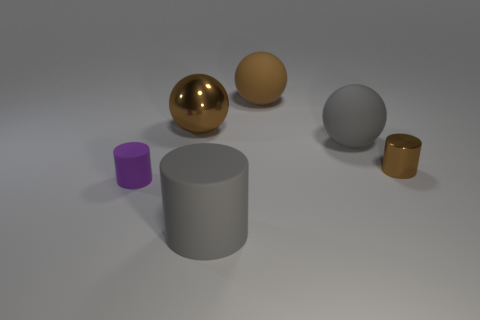Is the number of small brown shiny objects greater than the number of small red balls?
Ensure brevity in your answer.  Yes. What number of large objects are brown spheres or brown matte balls?
Your answer should be very brief. 2. What number of other objects are there of the same color as the large metallic thing?
Keep it short and to the point. 2. How many tiny things are the same material as the large gray cylinder?
Provide a succinct answer. 1. Does the cylinder that is behind the tiny purple object have the same color as the big metal thing?
Provide a short and direct response. Yes. What number of brown things are tiny rubber cylinders or metallic spheres?
Provide a succinct answer. 1. Are the object in front of the small purple matte cylinder and the brown cylinder made of the same material?
Your response must be concise. No. How many objects are big metallic spheres or shiny objects to the left of the brown metallic cylinder?
Provide a succinct answer. 1. What number of large cylinders are in front of the matte thing behind the big ball that is left of the large gray rubber cylinder?
Provide a succinct answer. 1. There is a large matte thing behind the large gray ball; is it the same shape as the big metal object?
Give a very brief answer. Yes. 